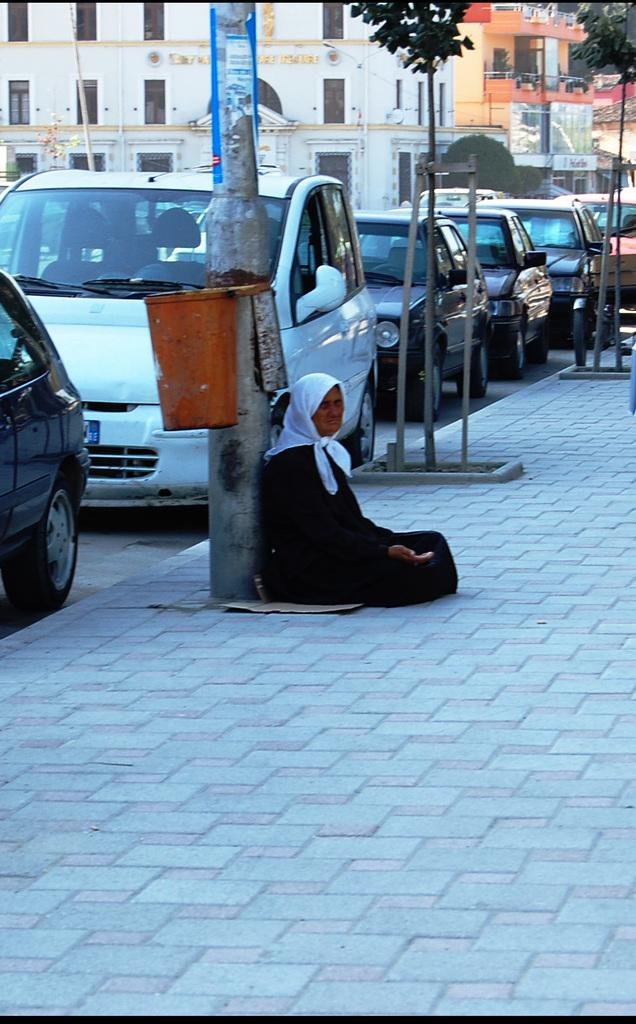What is the person in the image doing? There is a person sitting in the image. What can be seen on the road in the image? There are vehicles parked on the road in the image. What type of natural elements are visible in the image? There are trees visible in the image. What type of structures can be seen in the background of the image? There are buildings in the background of the image. Can you see any ducks swimming in the water near the person in the image? There is no water or ducks present in the image. Is there a birthday celebration happening in the image? There is no indication of a birthday celebration in the image. 